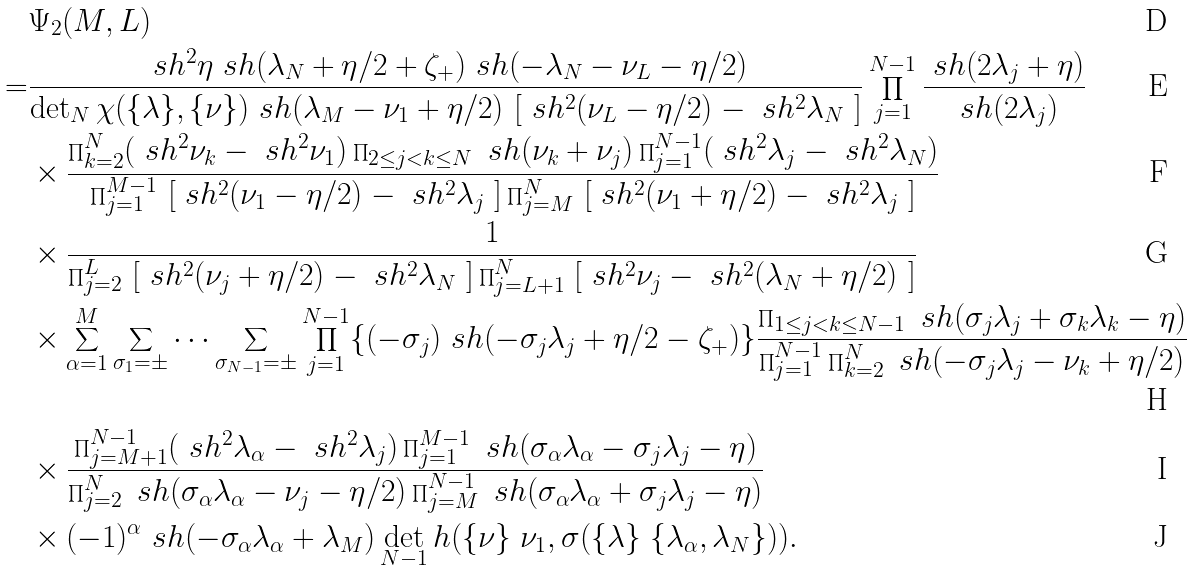Convert formula to latex. <formula><loc_0><loc_0><loc_500><loc_500>& \Psi _ { 2 } ( M , L ) \\ = & \frac { \ s h ^ { 2 } \eta \ s h ( \lambda _ { N } + \eta / 2 + \zeta _ { + } ) \ s h ( - \lambda _ { N } - \nu _ { L } - \eta / 2 ) } { \det _ { N } \chi ( \{ \lambda \} , \{ \nu \} ) \ s h ( \lambda _ { M } - \nu _ { 1 } + \eta / 2 ) \ [ \ s h ^ { 2 } ( \nu _ { L } - \eta / 2 ) - \ s h ^ { 2 } \lambda _ { N } \ ] } \prod _ { j = 1 } ^ { N - 1 } \frac { \ s h ( 2 \lambda _ { j } + \eta ) } { \ s h ( 2 \lambda _ { j } ) } \\ & \times \frac { \prod _ { k = 2 } ^ { N } ( \ s h ^ { 2 } \nu _ { k } - \ s h ^ { 2 } \nu _ { 1 } ) \prod _ { 2 \leq j < k \leq N } \ s h ( \nu _ { k } + \nu _ { j } ) \prod _ { j = 1 } ^ { N - 1 } ( \ s h ^ { 2 } \lambda _ { j } - \ s h ^ { 2 } \lambda _ { N } ) } { \prod _ { j = 1 } ^ { M - 1 } \ [ \ s h ^ { 2 } ( \nu _ { 1 } - \eta / 2 ) - \ s h ^ { 2 } \lambda _ { j } \ ] \prod _ { j = M } ^ { N } \ [ \ s h ^ { 2 } ( \nu _ { 1 } + \eta / 2 ) - \ s h ^ { 2 } \lambda _ { j } \ ] } \\ & \times \frac { 1 } { \prod _ { j = 2 } ^ { L } \ [ \ s h ^ { 2 } ( \nu _ { j } + \eta / 2 ) - \ s h ^ { 2 } \lambda _ { N } \ ] \prod _ { j = L + 1 } ^ { N } \ [ \ s h ^ { 2 } \nu _ { j } - \ s h ^ { 2 } ( \lambda _ { N } + \eta / 2 ) \ ] } \\ & \times \sum _ { \alpha = 1 } ^ { M } \sum _ { \sigma _ { 1 } = \pm } \cdots \sum _ { \sigma _ { N - 1 } = \pm } \prod _ { j = 1 } ^ { N - 1 } \{ ( - \sigma _ { j } ) \ s h ( - \sigma _ { j } \lambda _ { j } + \eta / 2 - \zeta _ { + } ) \} \frac { \prod _ { 1 \leq j < k \leq N - 1 } \ s h ( \sigma _ { j } \lambda _ { j } + \sigma _ { k } \lambda _ { k } - \eta ) } { \prod _ { j = 1 } ^ { N - 1 } \prod _ { k = 2 } ^ { N } \ s h ( - \sigma _ { j } \lambda _ { j } - \nu _ { k } + \eta / 2 ) } \\ & \times \frac { \prod _ { j = M + 1 } ^ { N - 1 } ( \ s h ^ { 2 } \lambda _ { \alpha } - \ s h ^ { 2 } \lambda _ { j } ) \prod _ { j = 1 } ^ { M - 1 } \ s h ( \sigma _ { \alpha } \lambda _ { \alpha } - \sigma _ { j } \lambda _ { j } - \eta ) } { \prod _ { j = 2 } ^ { N } \ s h ( \sigma _ { \alpha } \lambda _ { \alpha } - \nu _ { j } - \eta / 2 ) \prod _ { j = M } ^ { N - 1 } \ s h ( \sigma _ { \alpha } \lambda _ { \alpha } + \sigma _ { j } \lambda _ { j } - \eta ) } \\ & \times ( - 1 ) ^ { \alpha } \ s h ( - \sigma _ { \alpha } \lambda _ { \alpha } + \lambda _ { M } ) \det _ { N - 1 } h ( \{ \nu \} \ \nu _ { 1 } , \sigma ( \{ \lambda \} \ \{ \lambda _ { \alpha } , \lambda _ { N } \} ) ) .</formula> 